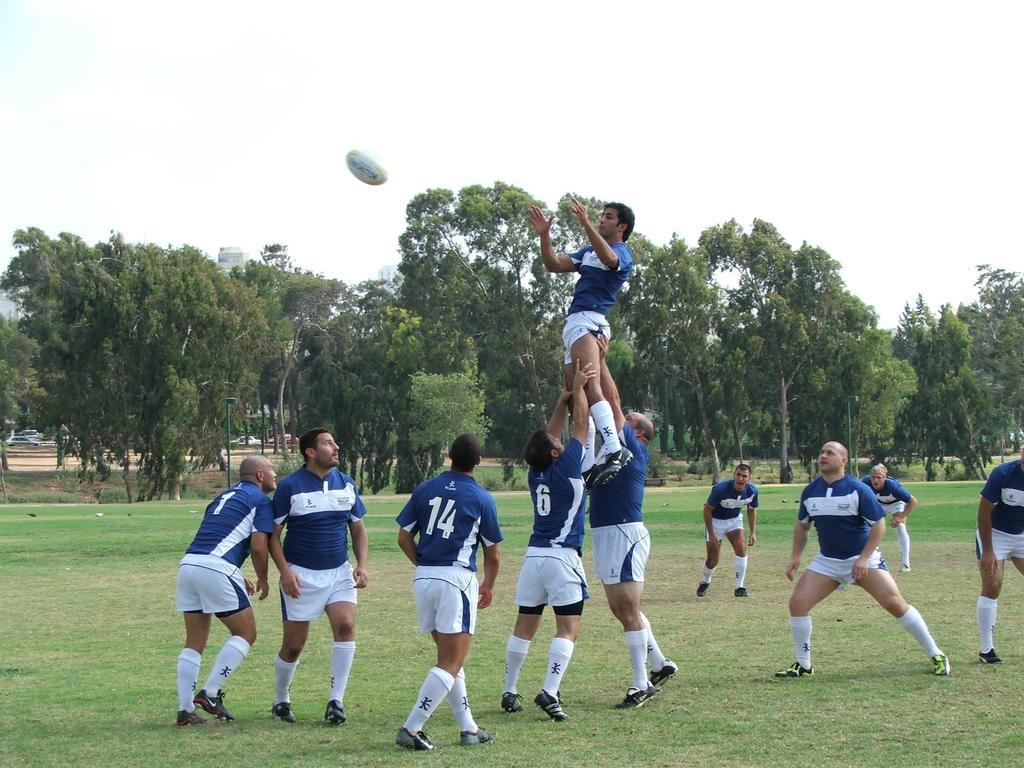<image>
Create a compact narrative representing the image presented. A group of rugby players in blue uniforms wait for the ball while number 6 and another hold up a player in the air. 